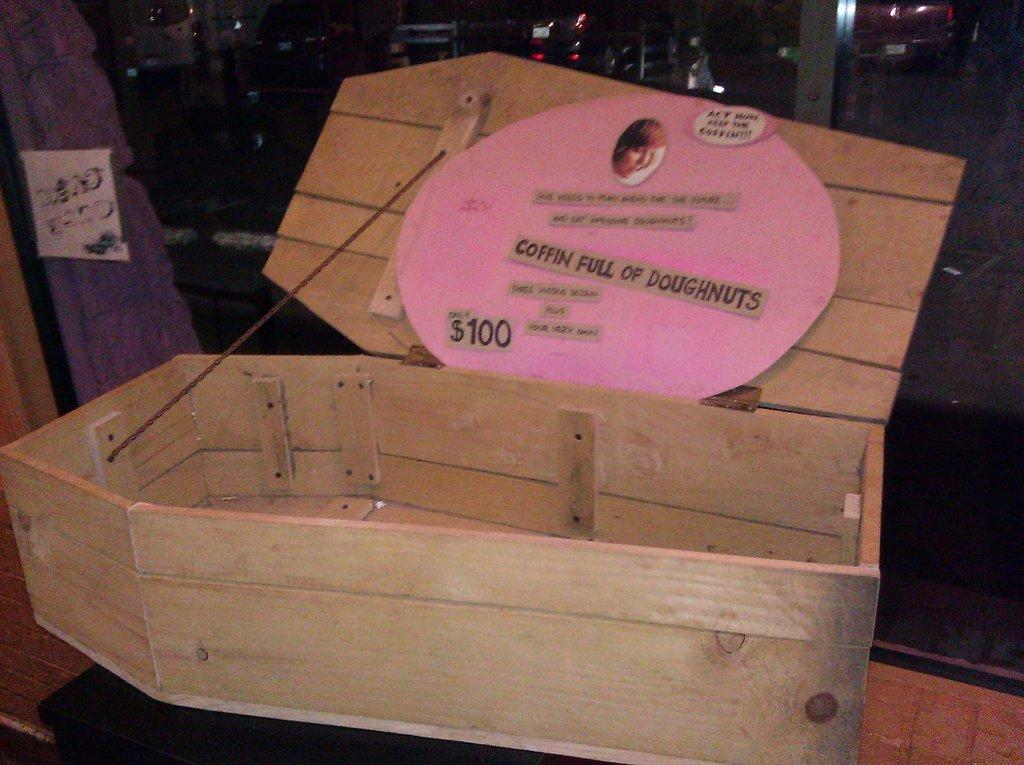<image>
Describe the image concisely. A coffin has a pink sign with a one hundred dollar price tag on it. 